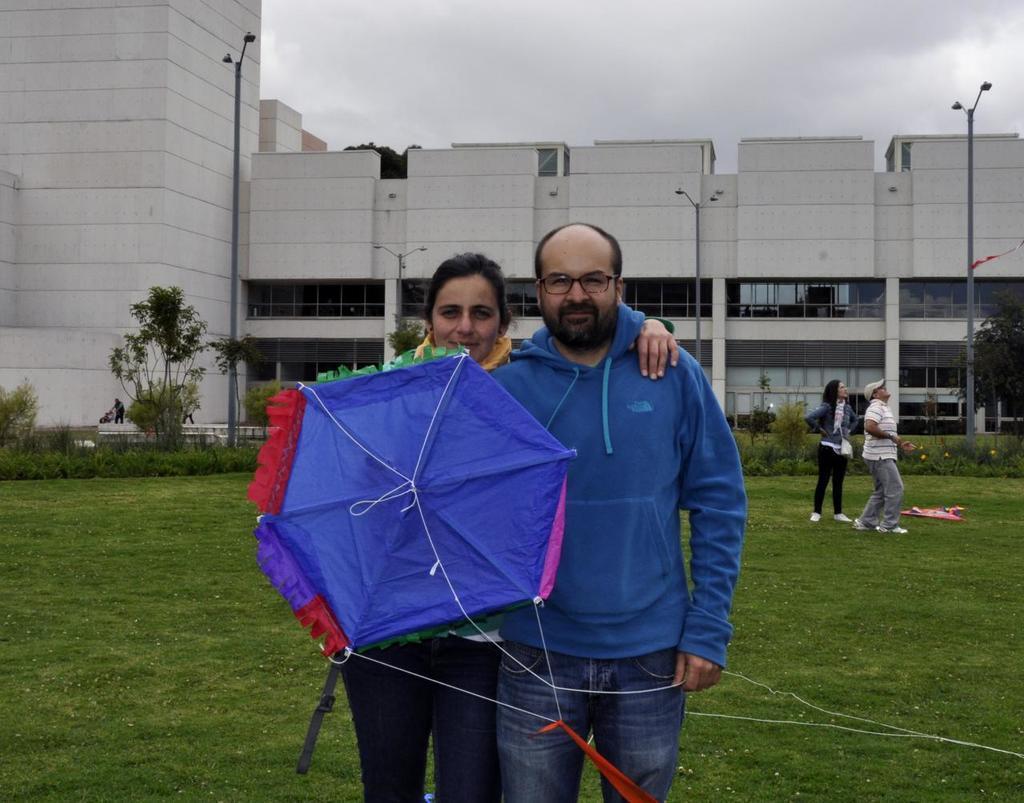Could you give a brief overview of what you see in this image? In this image we can see a man and a woman and there is an object which looks like a kite and there are two persons standing. We can see a building in the background and there are some plants, trees and grass on the ground and we can see few street lights and we can see the sky at the top. 